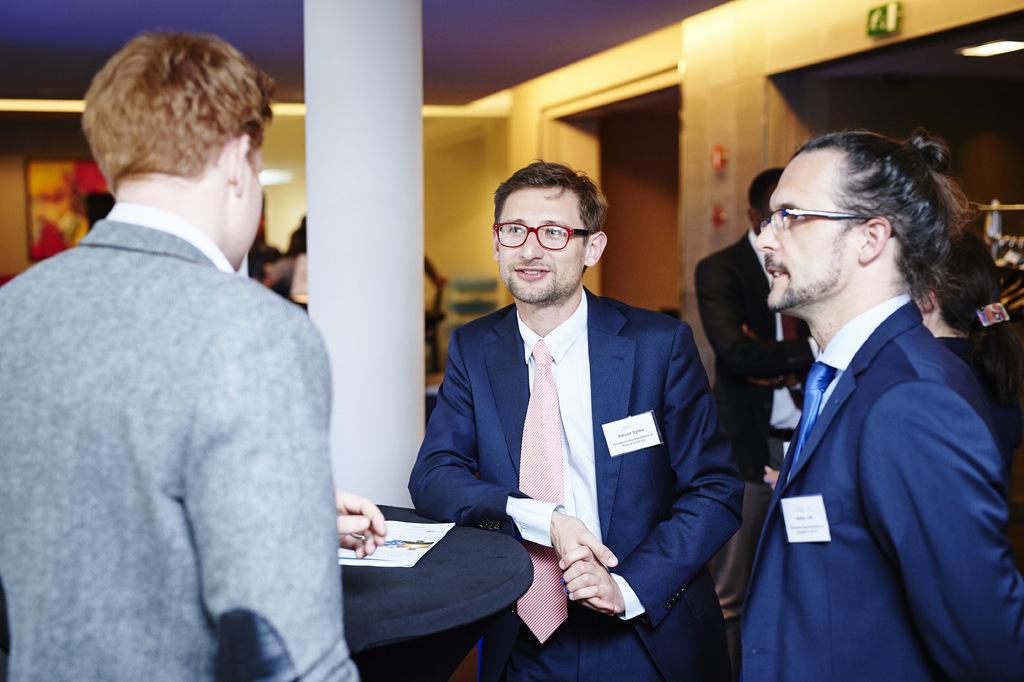Could you give a brief overview of what you see in this image? In this picture we can observe three men standing, wearing coats. Two of them are wearing spectacles. In the background there are some people standing. We can observe white color pillar here. There is yellow color wall in the background. 